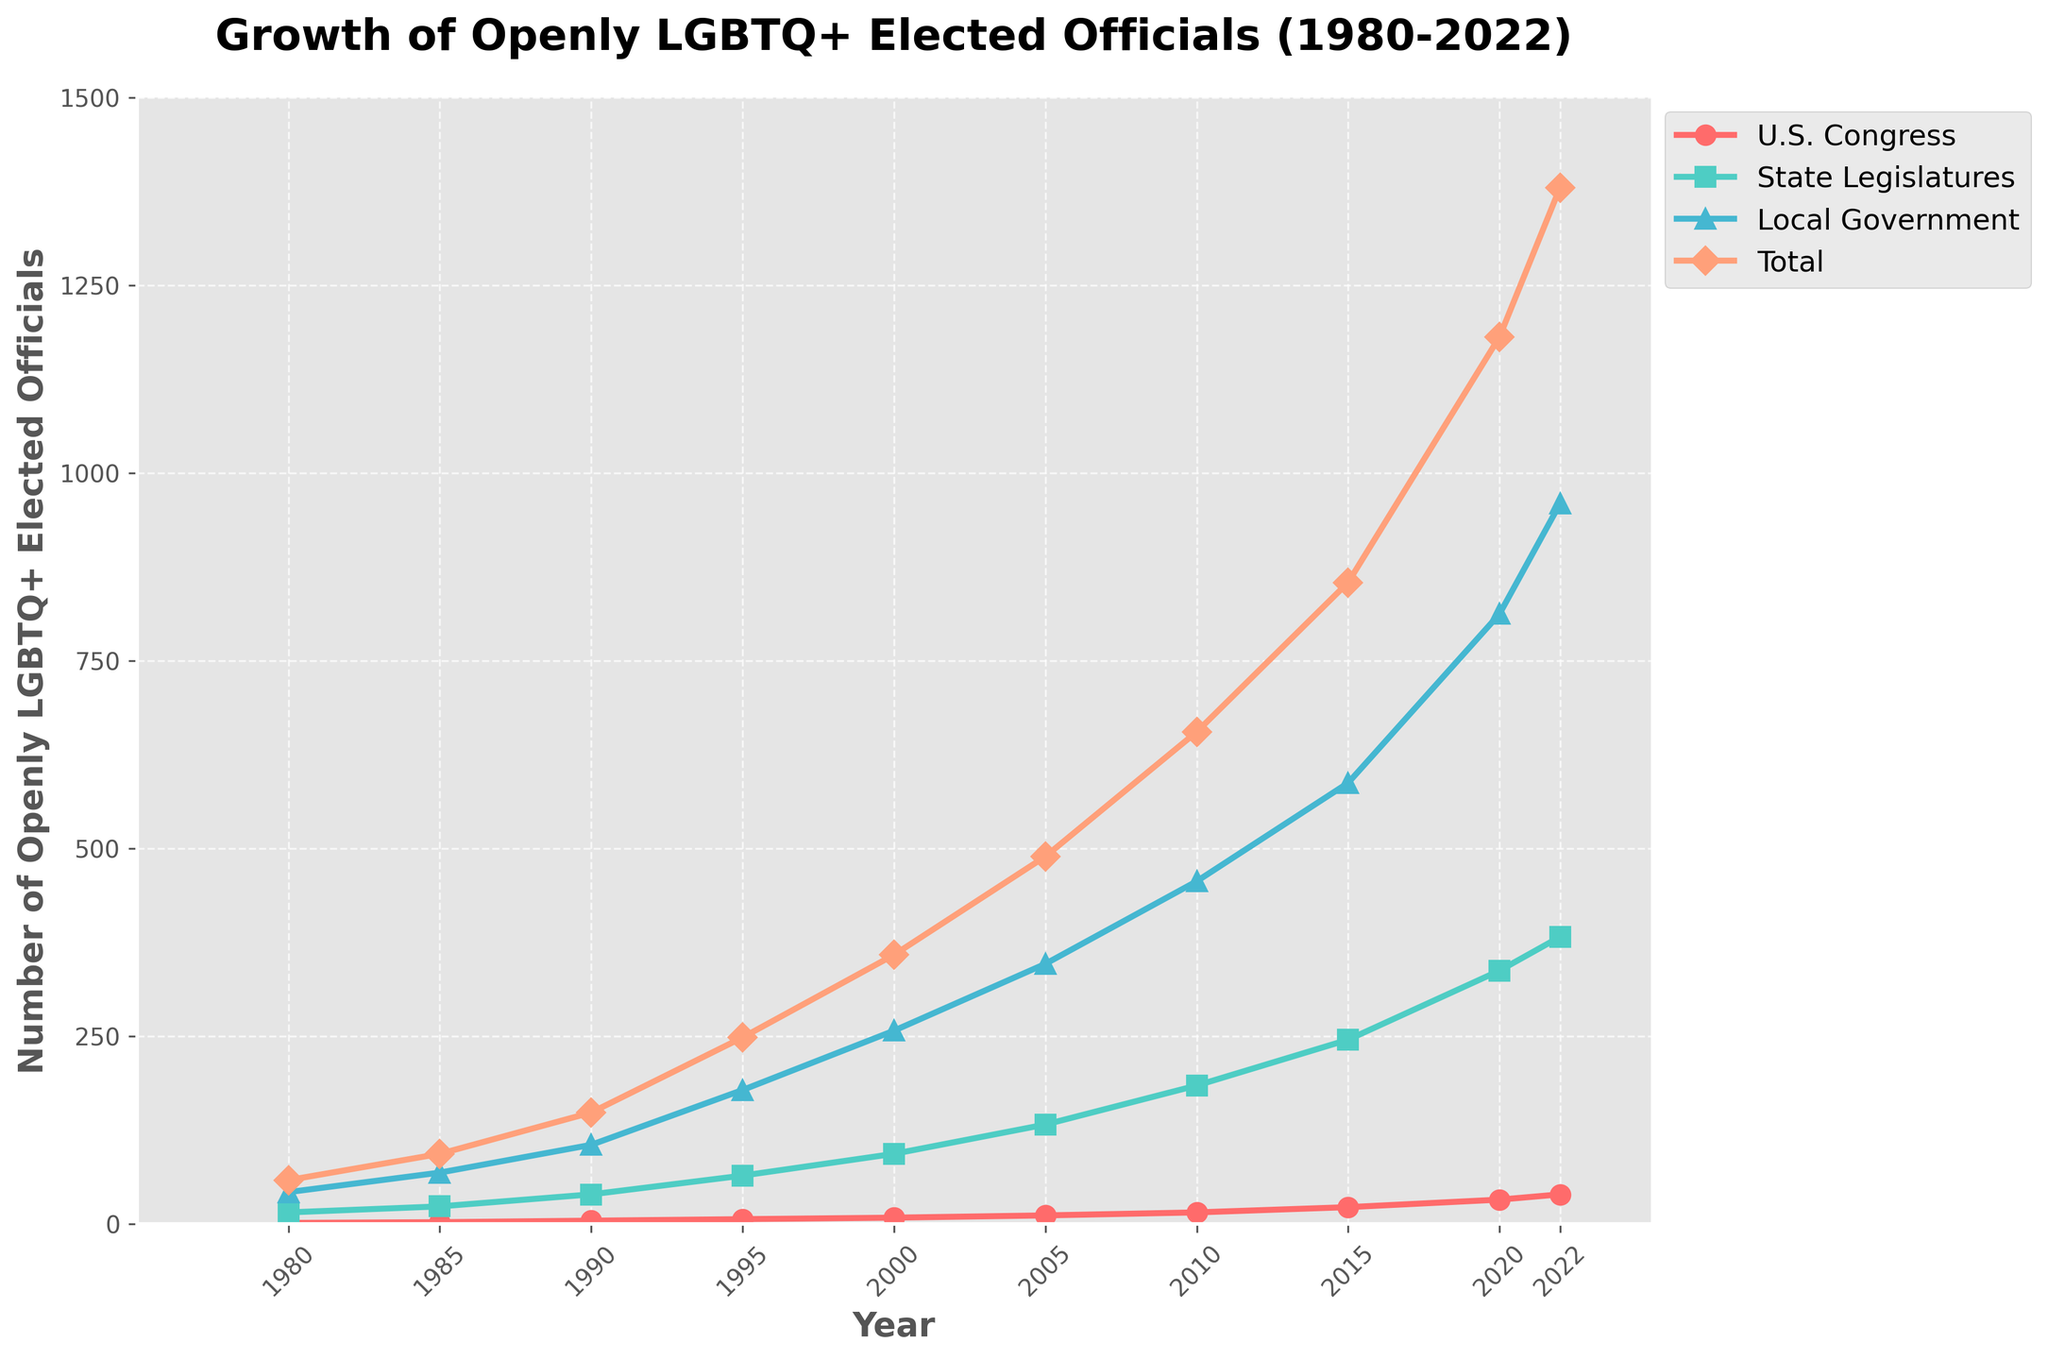What trend do you observe for the 'Total' number of openly LGBTQ+ elected officials from 1980 to 2022? The plot for 'Total' shows a consistent increase from 1980 (58 officials) to 2022 (1380 officials).
Answer: A consistent increase Which category saw the most significant increase between 1980 and 2022? By comparing the increase in numbers for each category, 'Local Government' rose from 42 in 1980 to 959 in 2022, showing the most significant increase.
Answer: Local Government In which year did the number of openly LGBTQ+ elected officials in the U.S. Congress first surpass 10? The line for 'U.S. Congress' surpasses the value of 10 between the years 2000 and 2005. Referring to the data, it first surpassed 10 in 2005.
Answer: 2005 How many more openly LGBTQ+ officials were there in state legislatures in 2022 compared to 2000? The number of officials in state legislatures in 2022 is 382, and in 2000 it was 93. The difference is 382 - 93 = 289.
Answer: 289 Calculate the average growth rate per year of the total number of openly LGBTQ+ elected officials from 1980 to 2022. The total number of officials grew from 58 in 1980 to 1380 in 2022, over 42 years. Average growth rate = (1380 - 58) / 42 ≈ 31.57 officials per year.
Answer: 31.57 officials per year Which year had the smallest increase in the number of openly LGBTQ+ elected officials in State Legislatures compared to the previous data point? By analyzing the plot, the smallest increase in State Legislatures is observed between 2020 and 2022 (from 337 to 382). Increase = 382 - 337 = 45.
Answer: 2020 to 2022 How does the number of openly LGBTQ+ elected officials in Local Government in 2022 compare to the Total number in 2010? In 2022, Local Government had 959 officials, which is greater than the total number in 2010, which was 655.
Answer: Local Government in 2022 had more officials In which period did the number of openly LGBTQ+ elected officials in U.S. Congress show the steepest increase? The line for U.S. Congress has its steepest slope between 2015 (22 officials) and 2020 (32 officials).
Answer: 2015 to 2020 Estimate the number of openly LGBTQ+ elected officials in State Legislatures in 2005 by looking at the plot. The plot indicates that in 2005, the number of openly LGBTQ+ officials in State Legislatures was slightly above 130, corresponding to 132 in the data.
Answer: 132 What is the difference in the number of openly LGBTQ+ elected officials between Local Government and U.S. Congress in 2022? In 2022, Local Government had 959 officials and U.S. Congress had 39. The difference is 959 - 39 = 920.
Answer: 920 